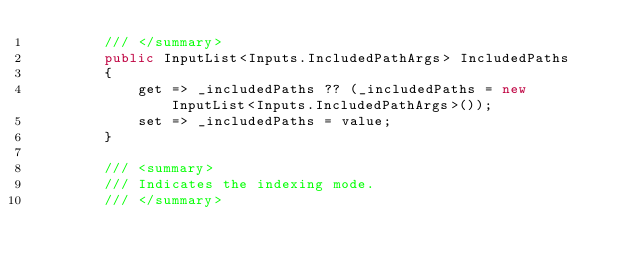<code> <loc_0><loc_0><loc_500><loc_500><_C#_>        /// </summary>
        public InputList<Inputs.IncludedPathArgs> IncludedPaths
        {
            get => _includedPaths ?? (_includedPaths = new InputList<Inputs.IncludedPathArgs>());
            set => _includedPaths = value;
        }

        /// <summary>
        /// Indicates the indexing mode.
        /// </summary></code> 